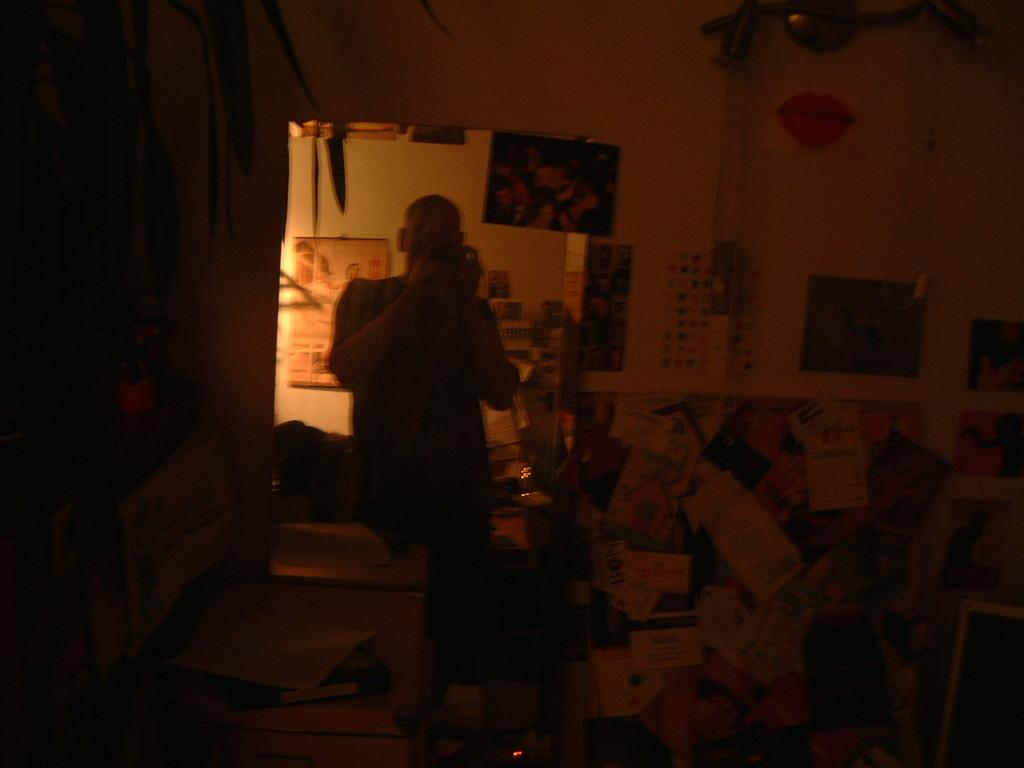Who or what is in the image? There is a person in the image. What is behind the person in the image? The person is in front of a wall. What can be seen on the wall in the image? There are charts and papers on the wall. What type of plastic is being used to hold the hot clam in the image? There is no plastic, hot clam, or any food item mentioned in the image. 